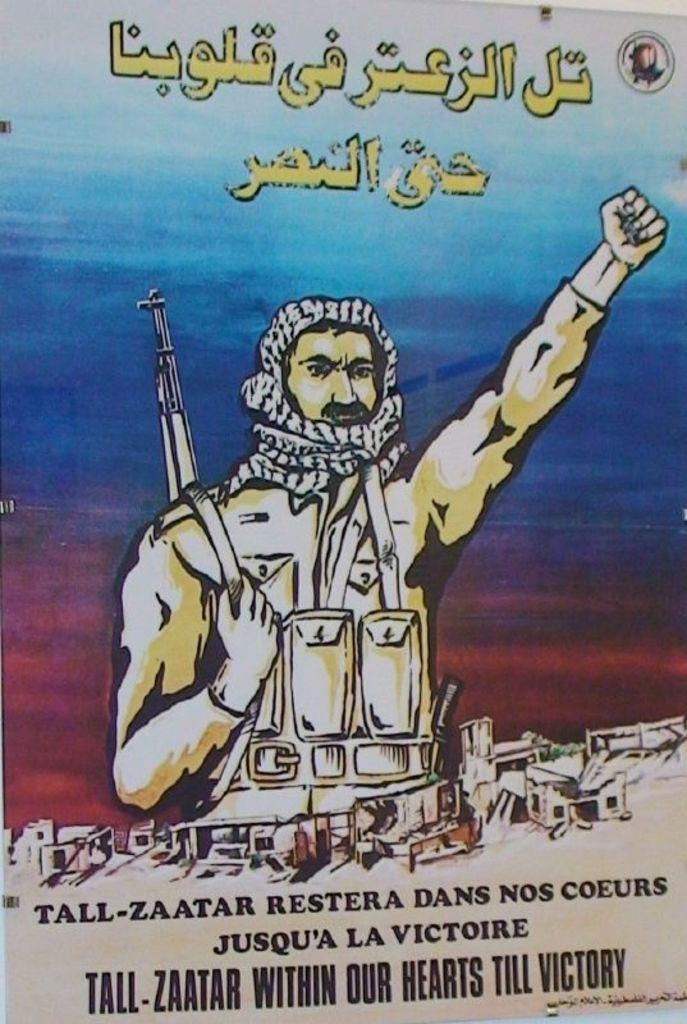<image>
Create a compact narrative representing the image presented. An Arabic language poster concerns a military figure known as Tall-Zaatar. 